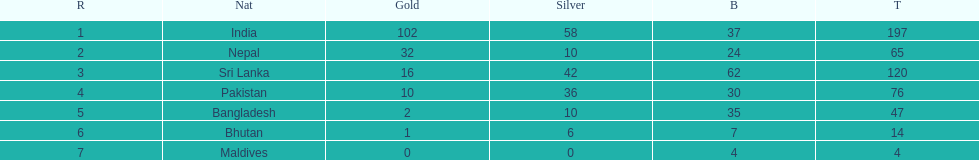How many gold medals did india win? 102. Could you help me parse every detail presented in this table? {'header': ['R', 'Nat', 'Gold', 'Silver', 'B', 'T'], 'rows': [['1', 'India', '102', '58', '37', '197'], ['2', 'Nepal', '32', '10', '24', '65'], ['3', 'Sri Lanka', '16', '42', '62', '120'], ['4', 'Pakistan', '10', '36', '30', '76'], ['5', 'Bangladesh', '2', '10', '35', '47'], ['6', 'Bhutan', '1', '6', '7', '14'], ['7', 'Maldives', '0', '0', '4', '4']]} 